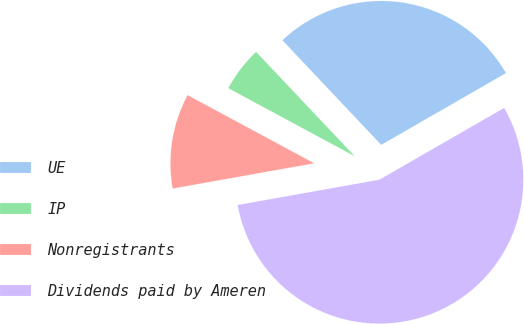Convert chart. <chart><loc_0><loc_0><loc_500><loc_500><pie_chart><fcel>UE<fcel>IP<fcel>Nonregistrants<fcel>Dividends paid by Ameren<nl><fcel>28.74%<fcel>5.09%<fcel>10.67%<fcel>55.5%<nl></chart> 